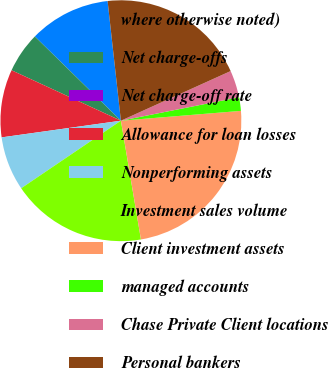Convert chart. <chart><loc_0><loc_0><loc_500><loc_500><pie_chart><fcel>where otherwise noted)<fcel>Net charge-offs<fcel>Net charge-off rate<fcel>Allowance for loan losses<fcel>Nonperforming assets<fcel>Investment sales volume<fcel>Client investment assets<fcel>managed accounts<fcel>Chase Private Client locations<fcel>Personal bankers<nl><fcel>10.91%<fcel>5.45%<fcel>0.0%<fcel>9.09%<fcel>7.27%<fcel>18.18%<fcel>23.64%<fcel>1.82%<fcel>3.64%<fcel>20.0%<nl></chart> 